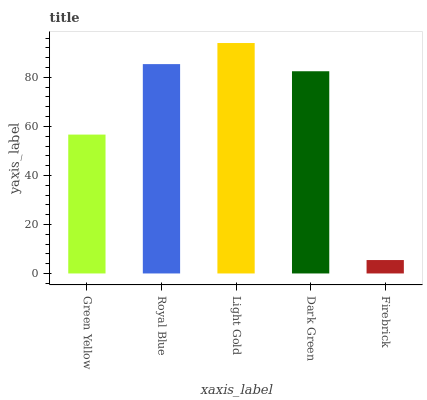Is Firebrick the minimum?
Answer yes or no. Yes. Is Light Gold the maximum?
Answer yes or no. Yes. Is Royal Blue the minimum?
Answer yes or no. No. Is Royal Blue the maximum?
Answer yes or no. No. Is Royal Blue greater than Green Yellow?
Answer yes or no. Yes. Is Green Yellow less than Royal Blue?
Answer yes or no. Yes. Is Green Yellow greater than Royal Blue?
Answer yes or no. No. Is Royal Blue less than Green Yellow?
Answer yes or no. No. Is Dark Green the high median?
Answer yes or no. Yes. Is Dark Green the low median?
Answer yes or no. Yes. Is Firebrick the high median?
Answer yes or no. No. Is Firebrick the low median?
Answer yes or no. No. 